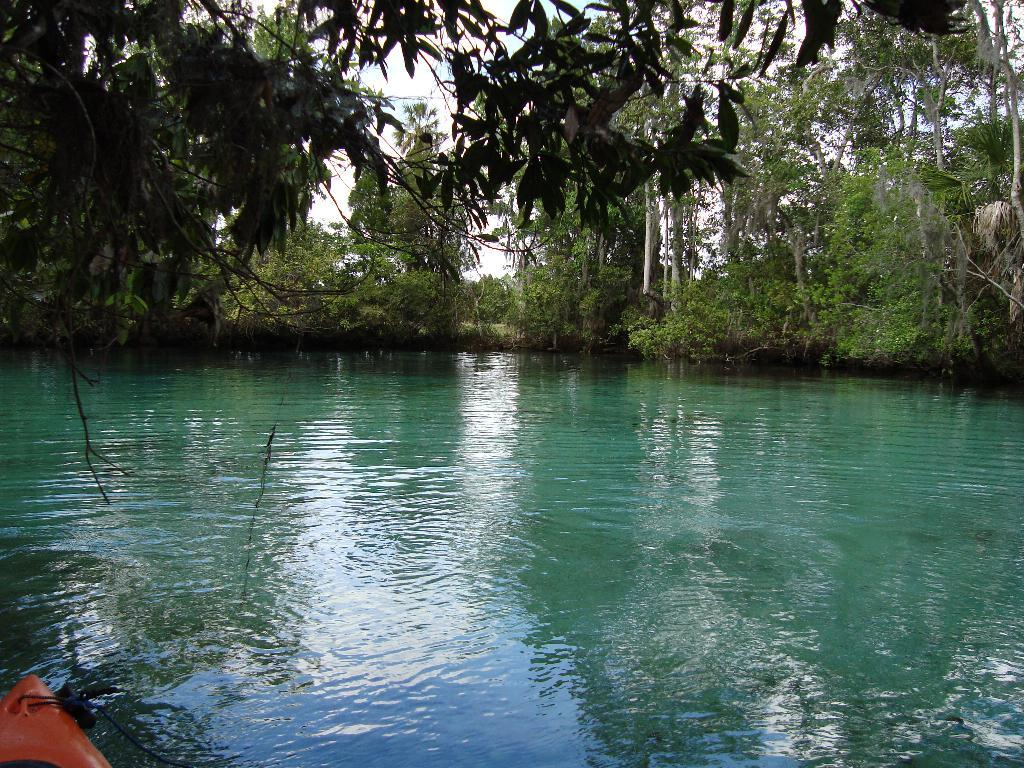What is present in the image that is not solid? There is water visible in the image. What can be seen in the bottom left of the image? There is an object in the bottom left of the image. What type of natural environment is visible in the background of the image? There are trees in the background of the image. What type of wood is the father using to whistle in the image? There is no father or whistling present in the image. 